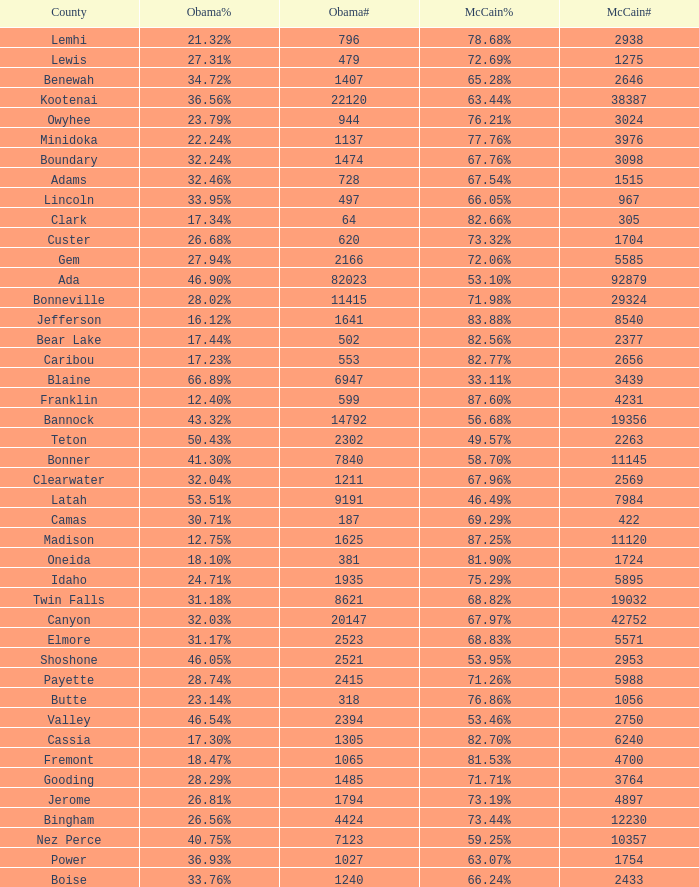What is the maximum McCain population turnout number? 92879.0. Give me the full table as a dictionary. {'header': ['County', 'Obama%', 'Obama#', 'McCain%', 'McCain#'], 'rows': [['Lemhi', '21.32%', '796', '78.68%', '2938'], ['Lewis', '27.31%', '479', '72.69%', '1275'], ['Benewah', '34.72%', '1407', '65.28%', '2646'], ['Kootenai', '36.56%', '22120', '63.44%', '38387'], ['Owyhee', '23.79%', '944', '76.21%', '3024'], ['Minidoka', '22.24%', '1137', '77.76%', '3976'], ['Boundary', '32.24%', '1474', '67.76%', '3098'], ['Adams', '32.46%', '728', '67.54%', '1515'], ['Lincoln', '33.95%', '497', '66.05%', '967'], ['Clark', '17.34%', '64', '82.66%', '305'], ['Custer', '26.68%', '620', '73.32%', '1704'], ['Gem', '27.94%', '2166', '72.06%', '5585'], ['Ada', '46.90%', '82023', '53.10%', '92879'], ['Bonneville', '28.02%', '11415', '71.98%', '29324'], ['Jefferson', '16.12%', '1641', '83.88%', '8540'], ['Bear Lake', '17.44%', '502', '82.56%', '2377'], ['Caribou', '17.23%', '553', '82.77%', '2656'], ['Blaine', '66.89%', '6947', '33.11%', '3439'], ['Franklin', '12.40%', '599', '87.60%', '4231'], ['Bannock', '43.32%', '14792', '56.68%', '19356'], ['Teton', '50.43%', '2302', '49.57%', '2263'], ['Bonner', '41.30%', '7840', '58.70%', '11145'], ['Clearwater', '32.04%', '1211', '67.96%', '2569'], ['Latah', '53.51%', '9191', '46.49%', '7984'], ['Camas', '30.71%', '187', '69.29%', '422'], ['Madison', '12.75%', '1625', '87.25%', '11120'], ['Oneida', '18.10%', '381', '81.90%', '1724'], ['Idaho', '24.71%', '1935', '75.29%', '5895'], ['Twin Falls', '31.18%', '8621', '68.82%', '19032'], ['Canyon', '32.03%', '20147', '67.97%', '42752'], ['Elmore', '31.17%', '2523', '68.83%', '5571'], ['Shoshone', '46.05%', '2521', '53.95%', '2953'], ['Payette', '28.74%', '2415', '71.26%', '5988'], ['Butte', '23.14%', '318', '76.86%', '1056'], ['Valley', '46.54%', '2394', '53.46%', '2750'], ['Cassia', '17.30%', '1305', '82.70%', '6240'], ['Fremont', '18.47%', '1065', '81.53%', '4700'], ['Gooding', '28.29%', '1485', '71.71%', '3764'], ['Jerome', '26.81%', '1794', '73.19%', '4897'], ['Bingham', '26.56%', '4424', '73.44%', '12230'], ['Nez Perce', '40.75%', '7123', '59.25%', '10357'], ['Power', '36.93%', '1027', '63.07%', '1754'], ['Boise', '33.76%', '1240', '66.24%', '2433']]} 